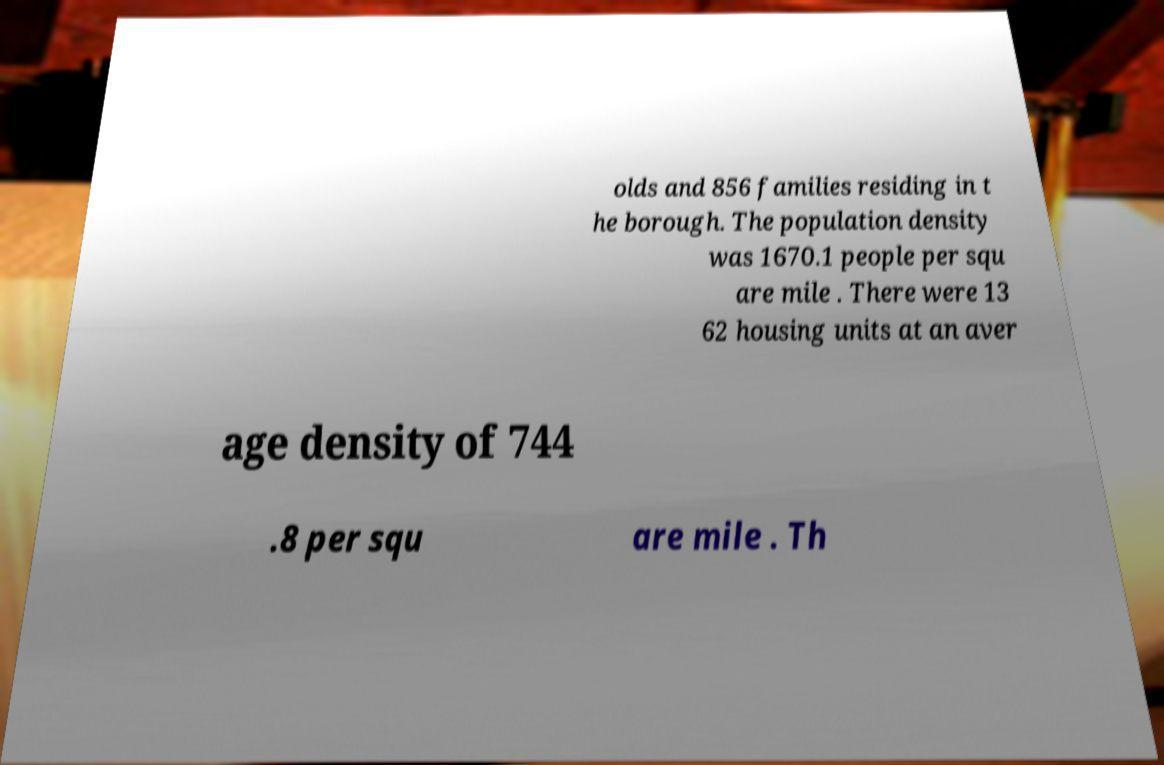Please identify and transcribe the text found in this image. olds and 856 families residing in t he borough. The population density was 1670.1 people per squ are mile . There were 13 62 housing units at an aver age density of 744 .8 per squ are mile . Th 